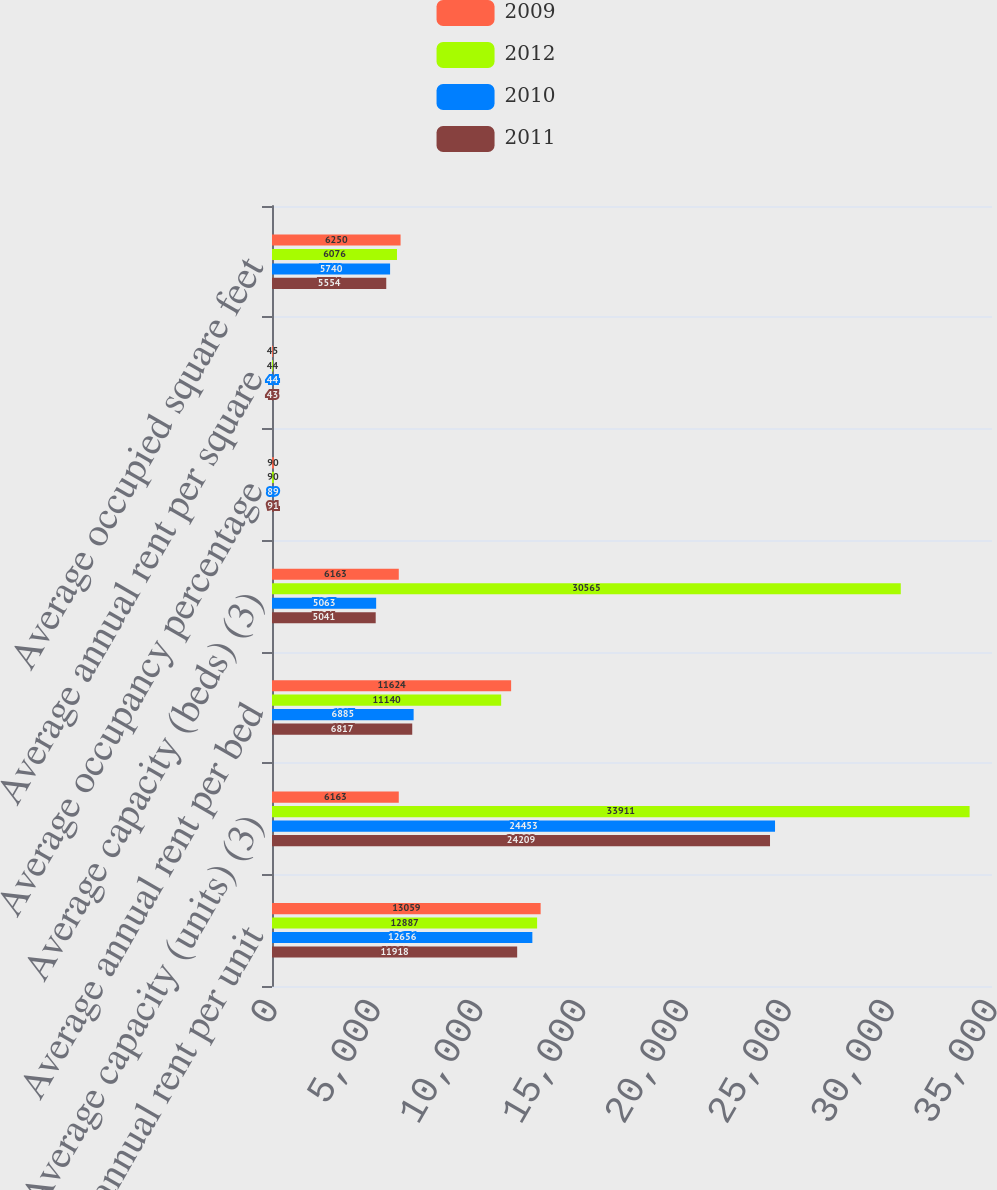Convert chart. <chart><loc_0><loc_0><loc_500><loc_500><stacked_bar_chart><ecel><fcel>Average annual rent per unit<fcel>Average capacity (units) (3)<fcel>Average annual rent per bed<fcel>Average capacity (beds) (3)<fcel>Average occupancy percentage<fcel>Average annual rent per square<fcel>Average occupied square feet<nl><fcel>2009<fcel>13059<fcel>6163<fcel>11624<fcel>6163<fcel>90<fcel>45<fcel>6250<nl><fcel>2012<fcel>12887<fcel>33911<fcel>11140<fcel>30565<fcel>90<fcel>44<fcel>6076<nl><fcel>2010<fcel>12656<fcel>24453<fcel>6885<fcel>5063<fcel>89<fcel>44<fcel>5740<nl><fcel>2011<fcel>11918<fcel>24209<fcel>6817<fcel>5041<fcel>91<fcel>43<fcel>5554<nl></chart> 